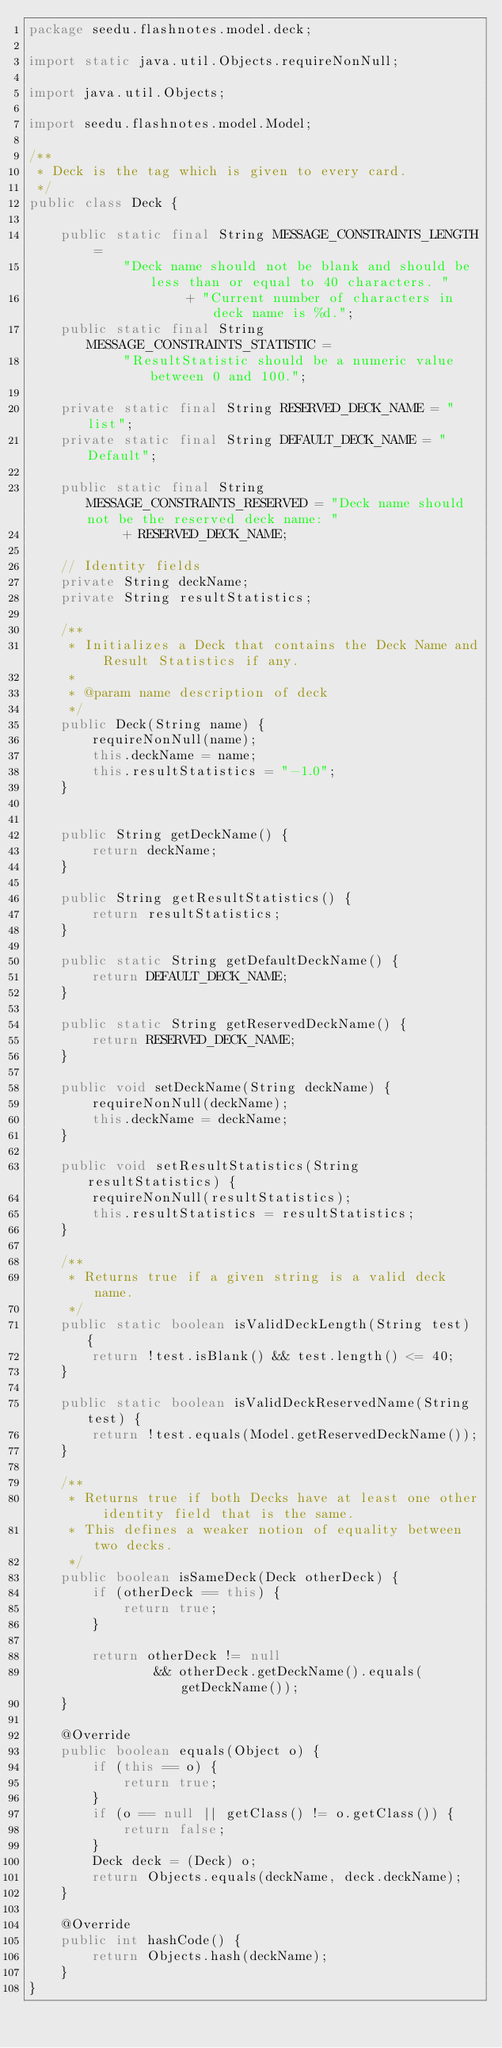<code> <loc_0><loc_0><loc_500><loc_500><_Java_>package seedu.flashnotes.model.deck;

import static java.util.Objects.requireNonNull;

import java.util.Objects;

import seedu.flashnotes.model.Model;

/**
 * Deck is the tag which is given to every card.
 */
public class Deck {

    public static final String MESSAGE_CONSTRAINTS_LENGTH =
            "Deck name should not be blank and should be less than or equal to 40 characters. "
                    + "Current number of characters in deck name is %d.";
    public static final String MESSAGE_CONSTRAINTS_STATISTIC =
            "ResultStatistic should be a numeric value between 0 and 100.";

    private static final String RESERVED_DECK_NAME = "list";
    private static final String DEFAULT_DECK_NAME = "Default";

    public static final String MESSAGE_CONSTRAINTS_RESERVED = "Deck name should not be the reserved deck name: "
            + RESERVED_DECK_NAME;

    // Identity fields
    private String deckName;
    private String resultStatistics;

    /**
     * Initializes a Deck that contains the Deck Name and Result Statistics if any.
     *
     * @param name description of deck
     */
    public Deck(String name) {
        requireNonNull(name);
        this.deckName = name;
        this.resultStatistics = "-1.0";
    }


    public String getDeckName() {
        return deckName;
    }

    public String getResultStatistics() {
        return resultStatistics;
    }

    public static String getDefaultDeckName() {
        return DEFAULT_DECK_NAME;
    }

    public static String getReservedDeckName() {
        return RESERVED_DECK_NAME;
    }

    public void setDeckName(String deckName) {
        requireNonNull(deckName);
        this.deckName = deckName;
    }

    public void setResultStatistics(String resultStatistics) {
        requireNonNull(resultStatistics);
        this.resultStatistics = resultStatistics;
    }

    /**
     * Returns true if a given string is a valid deck name.
     */
    public static boolean isValidDeckLength(String test) {
        return !test.isBlank() && test.length() <= 40;
    }

    public static boolean isValidDeckReservedName(String test) {
        return !test.equals(Model.getReservedDeckName());
    }

    /**
     * Returns true if both Decks have at least one other identity field that is the same.
     * This defines a weaker notion of equality between two decks.
     */
    public boolean isSameDeck(Deck otherDeck) {
        if (otherDeck == this) {
            return true;
        }

        return otherDeck != null
                && otherDeck.getDeckName().equals(getDeckName());
    }

    @Override
    public boolean equals(Object o) {
        if (this == o) {
            return true;
        }
        if (o == null || getClass() != o.getClass()) {
            return false;
        }
        Deck deck = (Deck) o;
        return Objects.equals(deckName, deck.deckName);
    }

    @Override
    public int hashCode() {
        return Objects.hash(deckName);
    }
}
</code> 